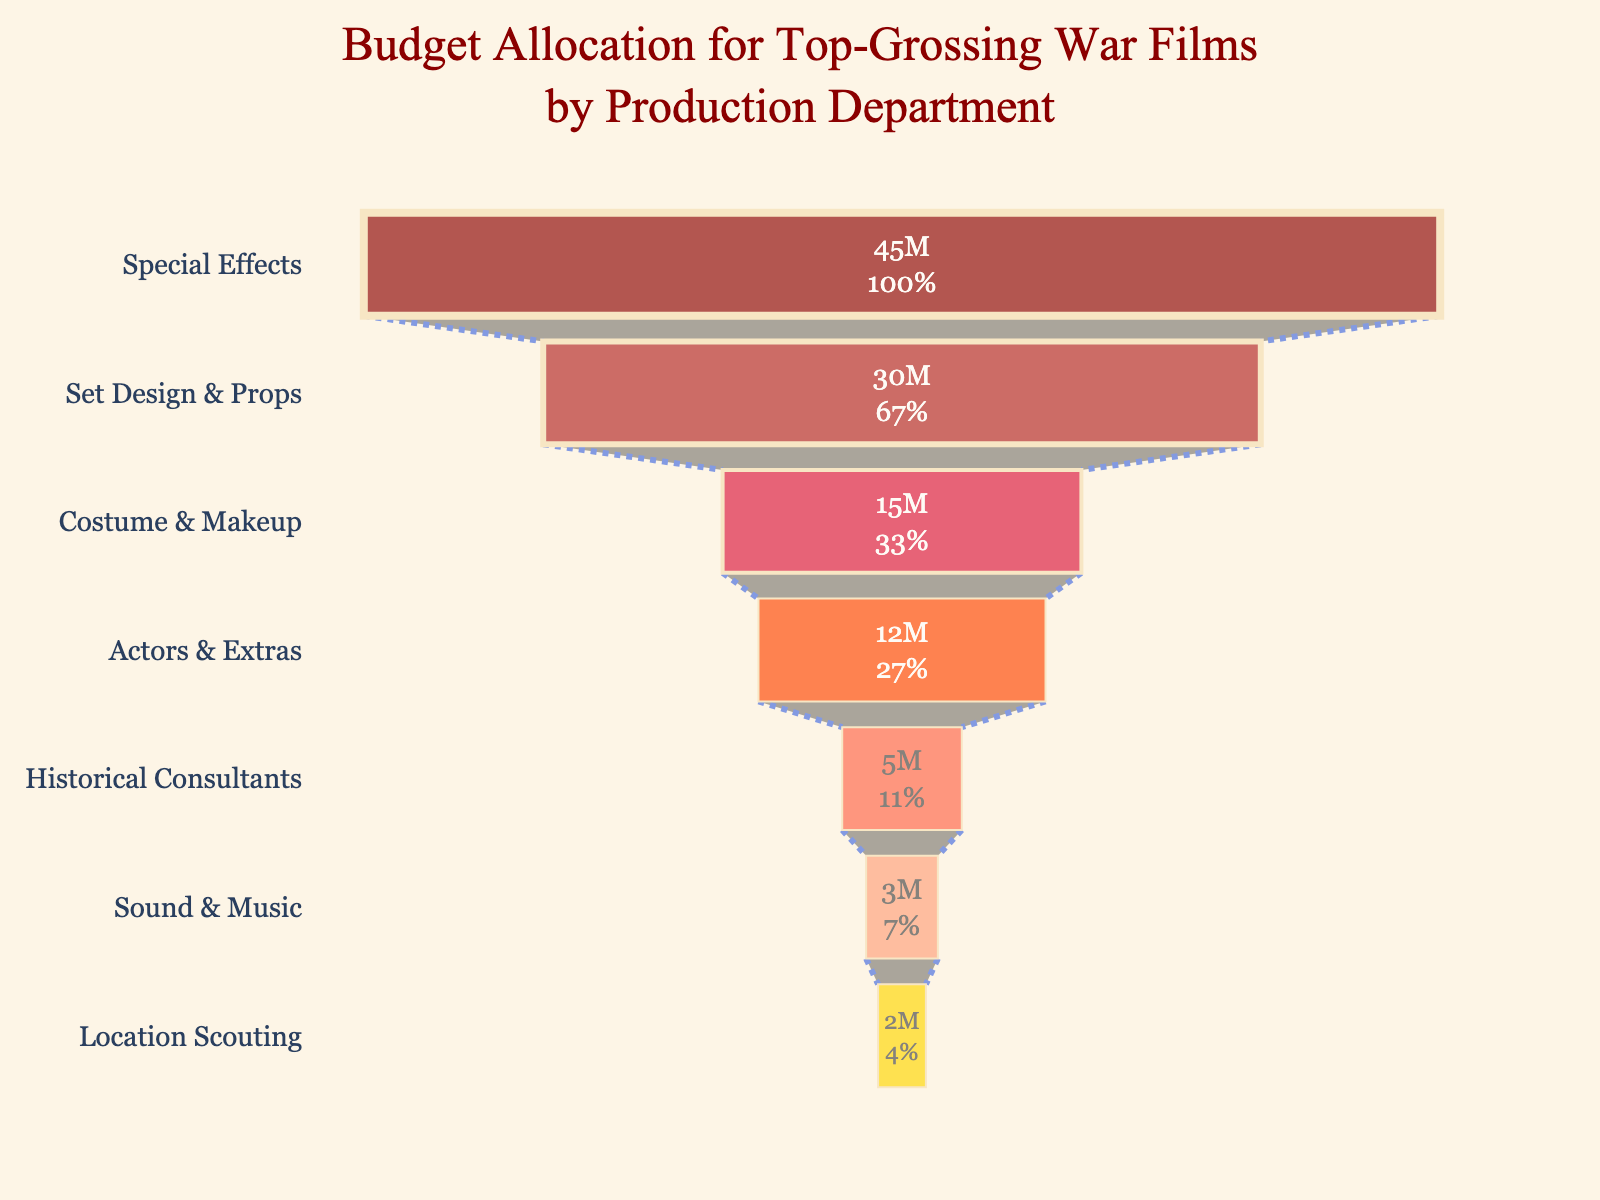What's the title of the figure? The title is located at the top of the figure.
Answer: Budget Allocation for Top-Grossing War Films by Production Department Which department has the highest budget allocation? The department with the longest bar at the top represents the highest budget allocation.
Answer: Special Effects What percentage of the total budget is allocated to Set Design & Props? The percentage is displayed inside the bar for Set Design & Props.
Answer: 20% How much more budget is allocated to Costumes & Makeup compared to Actors & Extras? Refer to the values inside each bar and subtract the budget for Actors & Extras from the budget for Costumes & Makeup. 15000000 - 12000000 is 3000000.
Answer: 3 million Which departments have a budget allocation of less than 5 million? Locate departments with values under 5 million inside their bars.
Answer: Historical Consultants, Sound & Music, Location Scouting What is the combined budget allocation for Historical Consultants and Sound & Music? Add the budget for Historical Consultants (5000000) and Sound & Music (3000000).
Answer: 8 million How many departments have a budget allocation shown in the figure? Count the total number of distinct bars or segments in the funnel chart.
Answer: 7 Is the budget allocation for Actors & Extras greater than or less than the budget allocation for Set Design & Props? Compare the budget values inside the bars for Actors & Extras and Set Design & Props.
Answer: Less than What is the total budget allocation for the top three departments? Sum the budget allocations for Special Effects, Set Design & Props, and Costumes & Makeup. 45000000 + 30000000 + 15000000 is 90000000.
Answer: 90 million How does the budget allocation for Location Scouting compare to Costume & Makeup? Compare the budget values inside the bars for Location Scouting and Costume & Makeup.
Answer: Less 